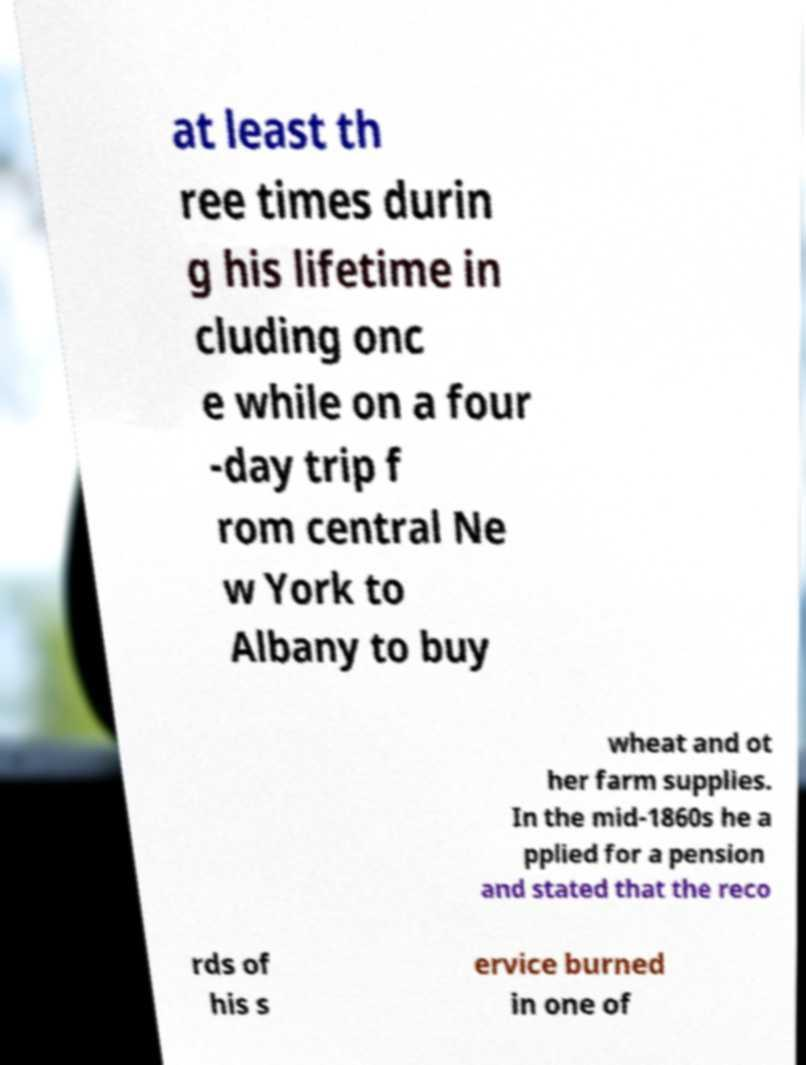Can you read and provide the text displayed in the image?This photo seems to have some interesting text. Can you extract and type it out for me? at least th ree times durin g his lifetime in cluding onc e while on a four -day trip f rom central Ne w York to Albany to buy wheat and ot her farm supplies. In the mid-1860s he a pplied for a pension and stated that the reco rds of his s ervice burned in one of 